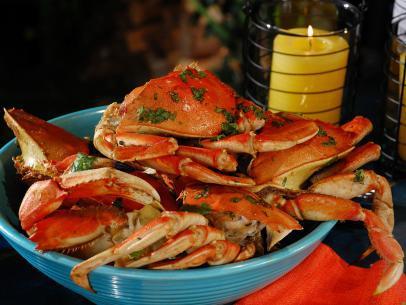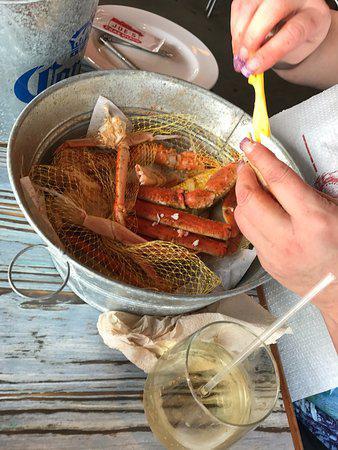The first image is the image on the left, the second image is the image on the right. Examine the images to the left and right. Is the description "Something yellow is in a round container behind crab legs in one image." accurate? Answer yes or no. Yes. The first image is the image on the left, the second image is the image on the right. Given the left and right images, does the statement "The crabs in both of the images sit in dishes." hold true? Answer yes or no. Yes. 